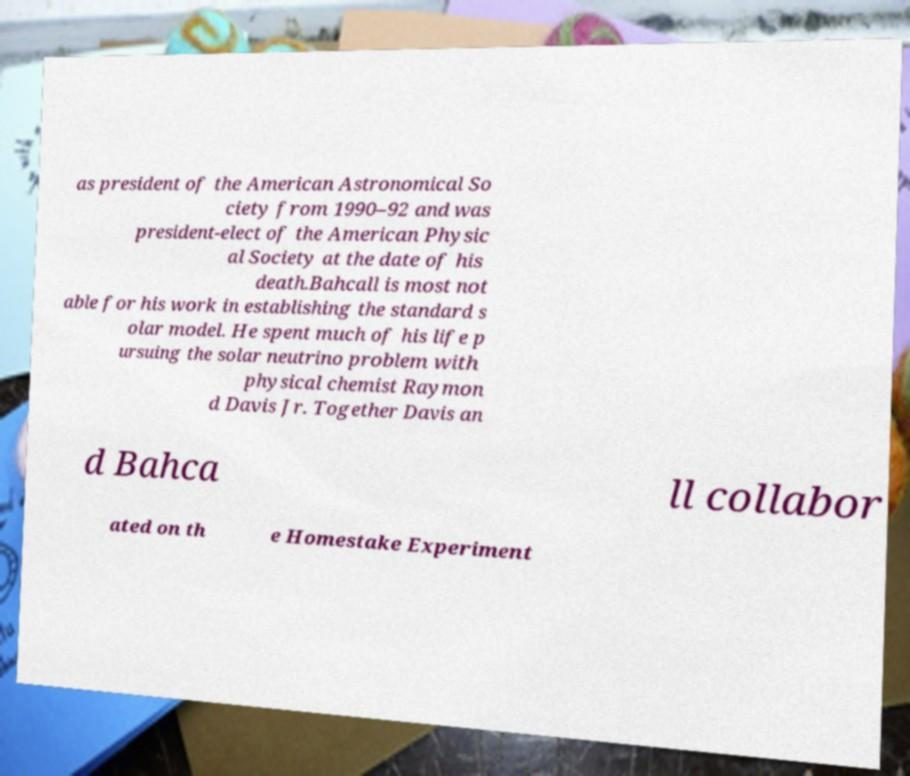Can you read and provide the text displayed in the image?This photo seems to have some interesting text. Can you extract and type it out for me? as president of the American Astronomical So ciety from 1990–92 and was president-elect of the American Physic al Society at the date of his death.Bahcall is most not able for his work in establishing the standard s olar model. He spent much of his life p ursuing the solar neutrino problem with physical chemist Raymon d Davis Jr. Together Davis an d Bahca ll collabor ated on th e Homestake Experiment 